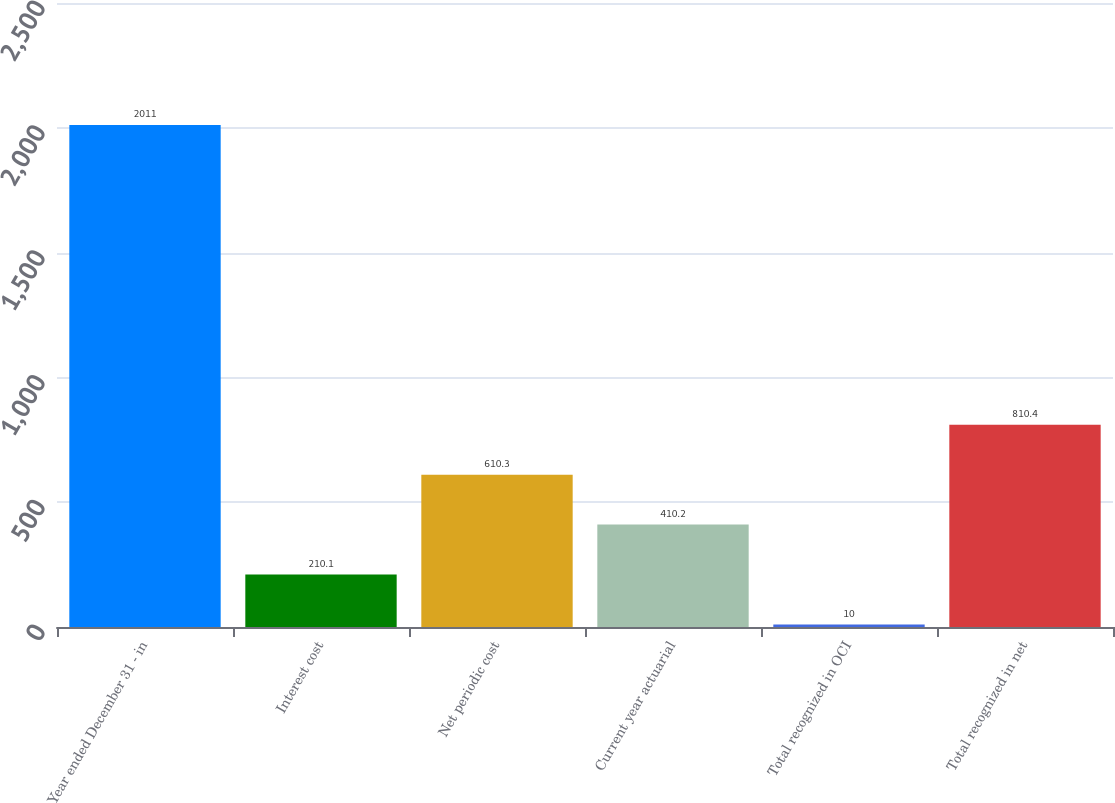<chart> <loc_0><loc_0><loc_500><loc_500><bar_chart><fcel>Year ended December 31 - in<fcel>Interest cost<fcel>Net periodic cost<fcel>Current year actuarial<fcel>Total recognized in OCI<fcel>Total recognized in net<nl><fcel>2011<fcel>210.1<fcel>610.3<fcel>410.2<fcel>10<fcel>810.4<nl></chart> 